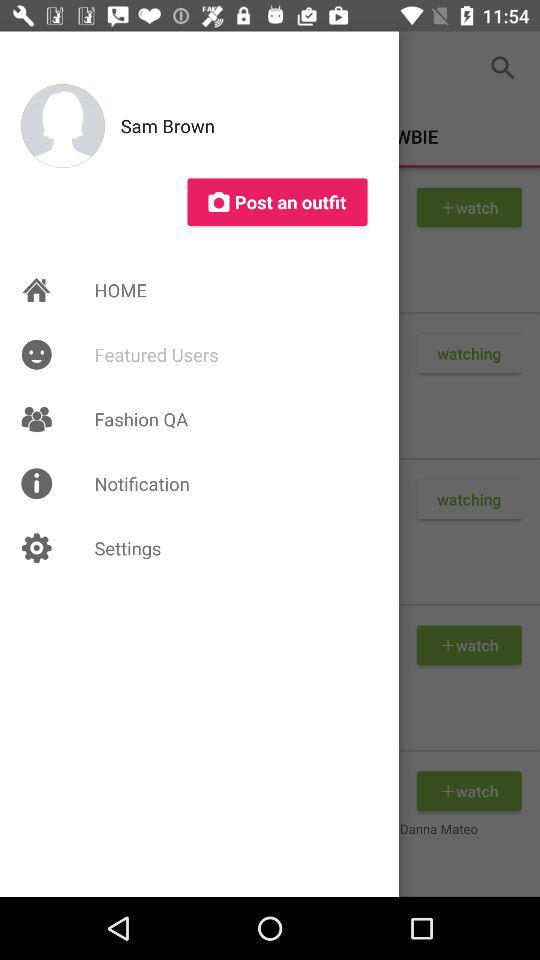What is the name of the user? The user name is Sam Brown. 